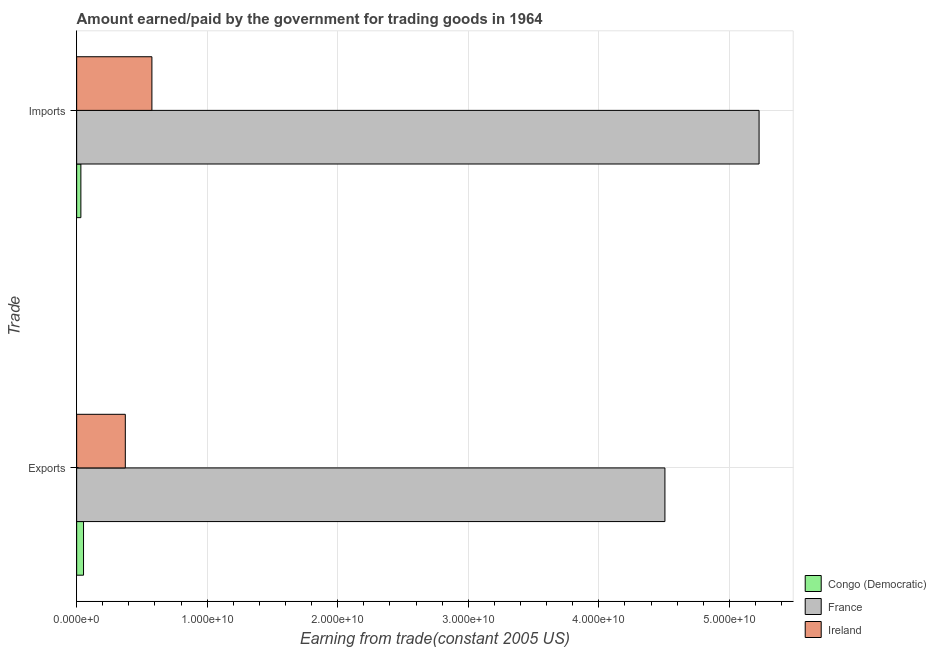How many different coloured bars are there?
Offer a very short reply. 3. How many groups of bars are there?
Ensure brevity in your answer.  2. What is the label of the 2nd group of bars from the top?
Give a very brief answer. Exports. What is the amount paid for imports in Congo (Democratic)?
Make the answer very short. 3.23e+08. Across all countries, what is the maximum amount earned from exports?
Make the answer very short. 4.51e+1. Across all countries, what is the minimum amount earned from exports?
Offer a very short reply. 5.26e+08. In which country was the amount earned from exports minimum?
Provide a short and direct response. Congo (Democratic). What is the total amount paid for imports in the graph?
Provide a succinct answer. 5.84e+1. What is the difference between the amount earned from exports in France and that in Congo (Democratic)?
Offer a terse response. 4.45e+1. What is the difference between the amount paid for imports in Congo (Democratic) and the amount earned from exports in Ireland?
Your response must be concise. -3.40e+09. What is the average amount earned from exports per country?
Keep it short and to the point. 1.64e+1. What is the difference between the amount earned from exports and amount paid for imports in France?
Keep it short and to the point. -7.21e+09. What is the ratio of the amount paid for imports in France to that in Congo (Democratic)?
Give a very brief answer. 161.93. In how many countries, is the amount earned from exports greater than the average amount earned from exports taken over all countries?
Offer a very short reply. 1. What does the 2nd bar from the top in Imports represents?
Your response must be concise. France. What does the 3rd bar from the bottom in Imports represents?
Your answer should be very brief. Ireland. How many bars are there?
Ensure brevity in your answer.  6. Are all the bars in the graph horizontal?
Your response must be concise. Yes. What is the difference between two consecutive major ticks on the X-axis?
Your response must be concise. 1.00e+1. Are the values on the major ticks of X-axis written in scientific E-notation?
Your answer should be compact. Yes. Where does the legend appear in the graph?
Give a very brief answer. Bottom right. What is the title of the graph?
Ensure brevity in your answer.  Amount earned/paid by the government for trading goods in 1964. Does "Slovak Republic" appear as one of the legend labels in the graph?
Give a very brief answer. No. What is the label or title of the X-axis?
Provide a succinct answer. Earning from trade(constant 2005 US). What is the label or title of the Y-axis?
Ensure brevity in your answer.  Trade. What is the Earning from trade(constant 2005 US) of Congo (Democratic) in Exports?
Keep it short and to the point. 5.26e+08. What is the Earning from trade(constant 2005 US) in France in Exports?
Your answer should be very brief. 4.51e+1. What is the Earning from trade(constant 2005 US) of Ireland in Exports?
Your answer should be very brief. 3.73e+09. What is the Earning from trade(constant 2005 US) in Congo (Democratic) in Imports?
Ensure brevity in your answer.  3.23e+08. What is the Earning from trade(constant 2005 US) of France in Imports?
Provide a succinct answer. 5.23e+1. What is the Earning from trade(constant 2005 US) in Ireland in Imports?
Offer a very short reply. 5.76e+09. Across all Trade, what is the maximum Earning from trade(constant 2005 US) in Congo (Democratic)?
Your answer should be compact. 5.26e+08. Across all Trade, what is the maximum Earning from trade(constant 2005 US) in France?
Ensure brevity in your answer.  5.23e+1. Across all Trade, what is the maximum Earning from trade(constant 2005 US) in Ireland?
Your answer should be very brief. 5.76e+09. Across all Trade, what is the minimum Earning from trade(constant 2005 US) of Congo (Democratic)?
Your response must be concise. 3.23e+08. Across all Trade, what is the minimum Earning from trade(constant 2005 US) of France?
Provide a short and direct response. 4.51e+1. Across all Trade, what is the minimum Earning from trade(constant 2005 US) in Ireland?
Provide a succinct answer. 3.73e+09. What is the total Earning from trade(constant 2005 US) in Congo (Democratic) in the graph?
Keep it short and to the point. 8.49e+08. What is the total Earning from trade(constant 2005 US) in France in the graph?
Make the answer very short. 9.73e+1. What is the total Earning from trade(constant 2005 US) of Ireland in the graph?
Offer a very short reply. 9.49e+09. What is the difference between the Earning from trade(constant 2005 US) in Congo (Democratic) in Exports and that in Imports?
Provide a succinct answer. 2.03e+08. What is the difference between the Earning from trade(constant 2005 US) of France in Exports and that in Imports?
Your answer should be very brief. -7.21e+09. What is the difference between the Earning from trade(constant 2005 US) of Ireland in Exports and that in Imports?
Your response must be concise. -2.04e+09. What is the difference between the Earning from trade(constant 2005 US) of Congo (Democratic) in Exports and the Earning from trade(constant 2005 US) of France in Imports?
Your answer should be compact. -5.18e+1. What is the difference between the Earning from trade(constant 2005 US) of Congo (Democratic) in Exports and the Earning from trade(constant 2005 US) of Ireland in Imports?
Make the answer very short. -5.24e+09. What is the difference between the Earning from trade(constant 2005 US) in France in Exports and the Earning from trade(constant 2005 US) in Ireland in Imports?
Your response must be concise. 3.93e+1. What is the average Earning from trade(constant 2005 US) of Congo (Democratic) per Trade?
Make the answer very short. 4.25e+08. What is the average Earning from trade(constant 2005 US) in France per Trade?
Your answer should be very brief. 4.87e+1. What is the average Earning from trade(constant 2005 US) of Ireland per Trade?
Make the answer very short. 4.75e+09. What is the difference between the Earning from trade(constant 2005 US) of Congo (Democratic) and Earning from trade(constant 2005 US) of France in Exports?
Keep it short and to the point. -4.45e+1. What is the difference between the Earning from trade(constant 2005 US) in Congo (Democratic) and Earning from trade(constant 2005 US) in Ireland in Exports?
Give a very brief answer. -3.20e+09. What is the difference between the Earning from trade(constant 2005 US) of France and Earning from trade(constant 2005 US) of Ireland in Exports?
Offer a terse response. 4.13e+1. What is the difference between the Earning from trade(constant 2005 US) of Congo (Democratic) and Earning from trade(constant 2005 US) of France in Imports?
Make the answer very short. -5.20e+1. What is the difference between the Earning from trade(constant 2005 US) of Congo (Democratic) and Earning from trade(constant 2005 US) of Ireland in Imports?
Provide a short and direct response. -5.44e+09. What is the difference between the Earning from trade(constant 2005 US) in France and Earning from trade(constant 2005 US) in Ireland in Imports?
Your response must be concise. 4.65e+1. What is the ratio of the Earning from trade(constant 2005 US) in Congo (Democratic) in Exports to that in Imports?
Ensure brevity in your answer.  1.63. What is the ratio of the Earning from trade(constant 2005 US) of France in Exports to that in Imports?
Keep it short and to the point. 0.86. What is the ratio of the Earning from trade(constant 2005 US) of Ireland in Exports to that in Imports?
Ensure brevity in your answer.  0.65. What is the difference between the highest and the second highest Earning from trade(constant 2005 US) in Congo (Democratic)?
Provide a succinct answer. 2.03e+08. What is the difference between the highest and the second highest Earning from trade(constant 2005 US) in France?
Provide a succinct answer. 7.21e+09. What is the difference between the highest and the second highest Earning from trade(constant 2005 US) in Ireland?
Offer a very short reply. 2.04e+09. What is the difference between the highest and the lowest Earning from trade(constant 2005 US) of Congo (Democratic)?
Keep it short and to the point. 2.03e+08. What is the difference between the highest and the lowest Earning from trade(constant 2005 US) of France?
Provide a succinct answer. 7.21e+09. What is the difference between the highest and the lowest Earning from trade(constant 2005 US) of Ireland?
Your answer should be compact. 2.04e+09. 